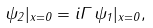Convert formula to latex. <formula><loc_0><loc_0><loc_500><loc_500>\psi _ { 2 } | _ { x = 0 } = i \Gamma \, \psi _ { 1 } | _ { x = 0 } ,</formula> 